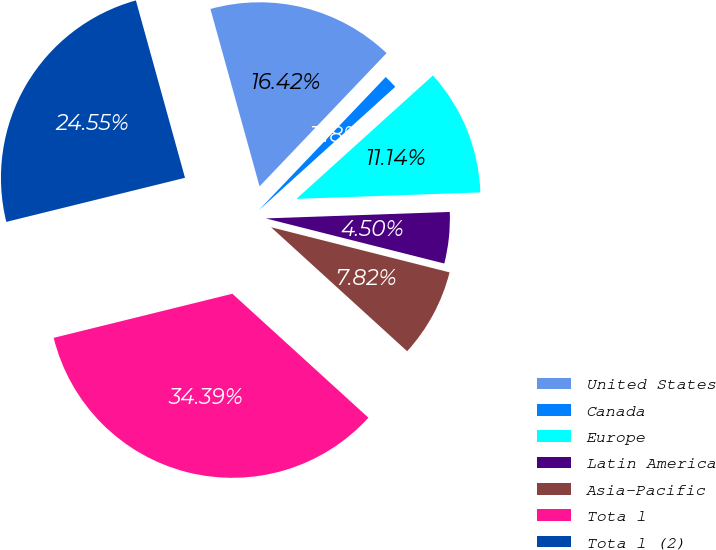Convert chart. <chart><loc_0><loc_0><loc_500><loc_500><pie_chart><fcel>United States<fcel>Canada<fcel>Europe<fcel>Latin America<fcel>Asia-Pacific<fcel>Tota l<fcel>Tota l (2)<nl><fcel>16.42%<fcel>1.18%<fcel>11.14%<fcel>4.5%<fcel>7.82%<fcel>34.39%<fcel>24.55%<nl></chart> 